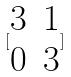Convert formula to latex. <formula><loc_0><loc_0><loc_500><loc_500>[ \begin{matrix} 3 & 1 \\ 0 & 3 \end{matrix} ]</formula> 